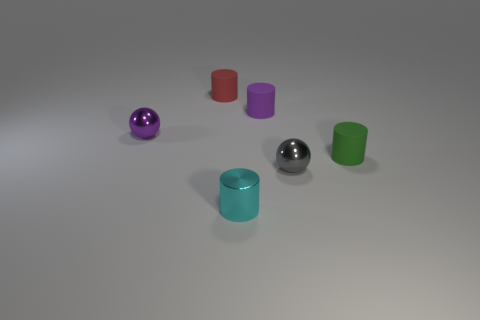How many objects are there in total, and can you describe their colors and shapes? In total, there are six objects. Starting from the left, there's a purple sphere and a red cylinder, followed by a silver sphere. Next to them, we see a cyan cylinder, a silver sphere again, and finally, a green cylinder. 